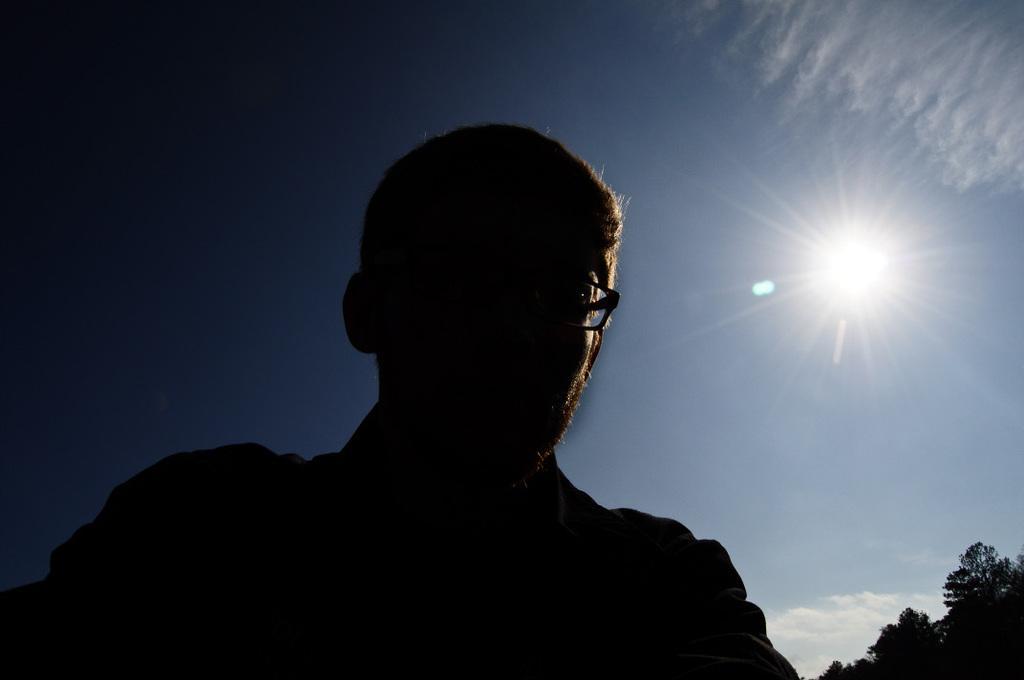Could you give a brief overview of what you see in this image? This picture is clicked outside. In the foreground there is a man. In the background there is a sky, sun and the trees. 